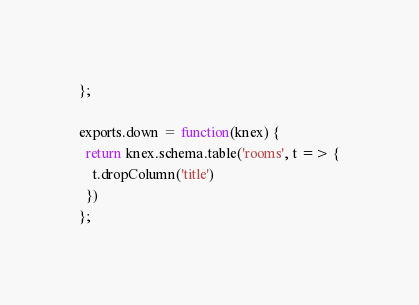<code> <loc_0><loc_0><loc_500><loc_500><_JavaScript_>};

exports.down = function(knex) {
  return knex.schema.table('rooms', t => {
    t.dropColumn('title')
  })
};
</code> 